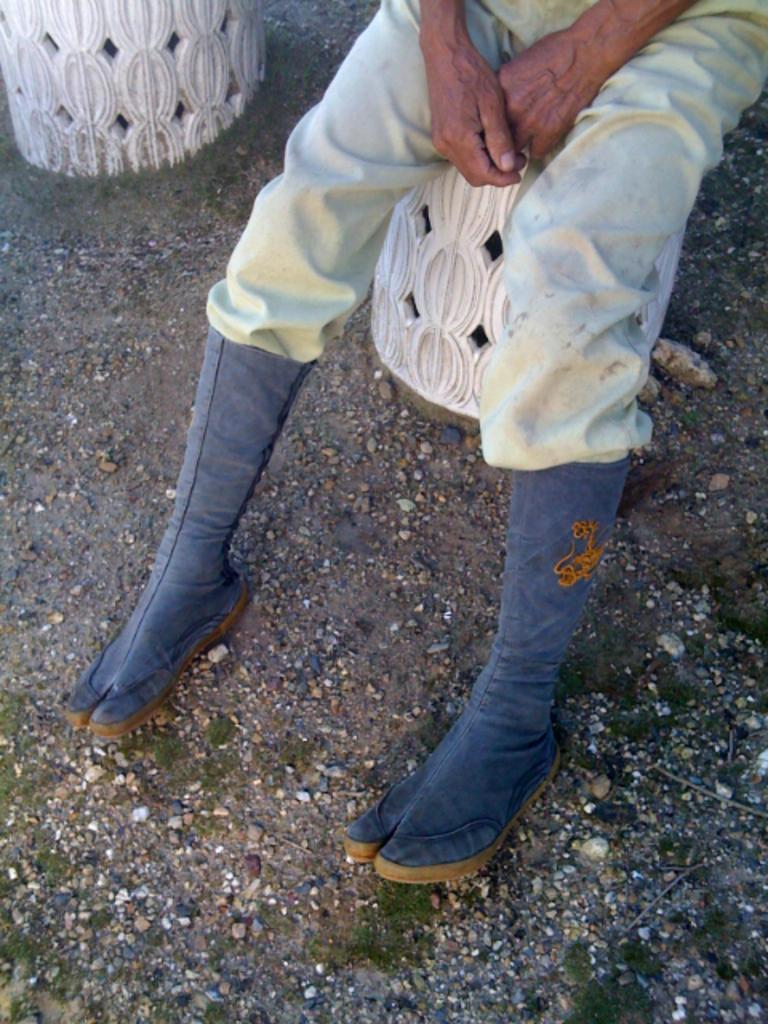Please provide a concise description of this image. Here in this picture we can see a person sitting over a place and we can see he is wearing boots on his legs and we can see grass present on the ground here and there. 